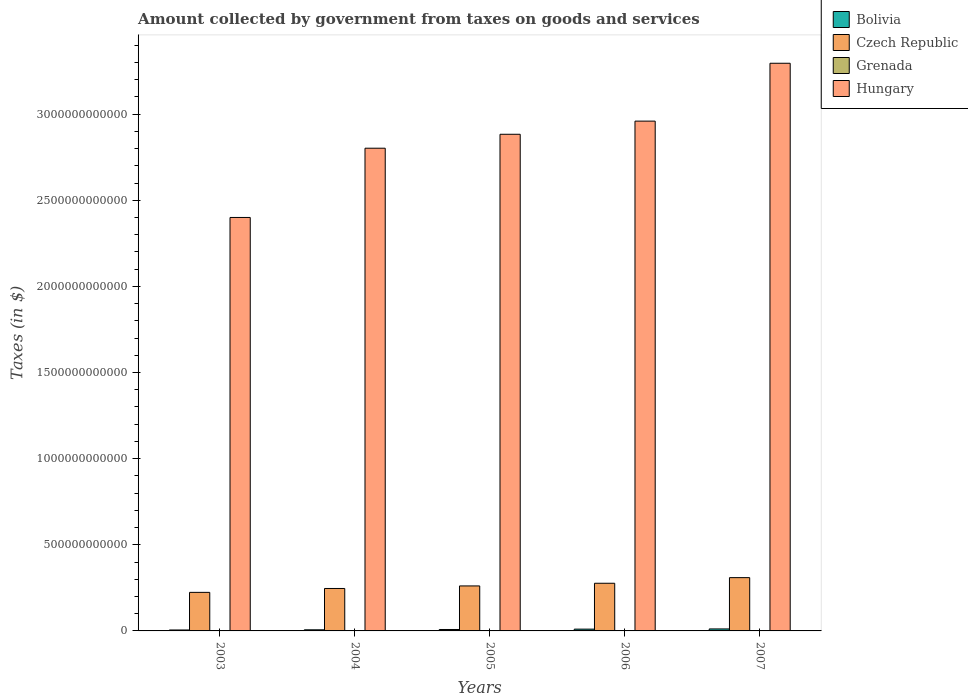Are the number of bars per tick equal to the number of legend labels?
Offer a terse response. Yes. How many bars are there on the 5th tick from the left?
Provide a succinct answer. 4. How many bars are there on the 5th tick from the right?
Your answer should be compact. 4. What is the label of the 2nd group of bars from the left?
Provide a succinct answer. 2004. What is the amount collected by government from taxes on goods and services in Czech Republic in 2003?
Your answer should be very brief. 2.24e+11. Across all years, what is the maximum amount collected by government from taxes on goods and services in Bolivia?
Give a very brief answer. 1.15e+1. Across all years, what is the minimum amount collected by government from taxes on goods and services in Czech Republic?
Provide a succinct answer. 2.24e+11. In which year was the amount collected by government from taxes on goods and services in Grenada minimum?
Your response must be concise. 2004. What is the total amount collected by government from taxes on goods and services in Grenada in the graph?
Offer a very short reply. 3.11e+08. What is the difference between the amount collected by government from taxes on goods and services in Grenada in 2005 and that in 2006?
Give a very brief answer. -9.10e+06. What is the difference between the amount collected by government from taxes on goods and services in Hungary in 2007 and the amount collected by government from taxes on goods and services in Czech Republic in 2006?
Make the answer very short. 3.02e+12. What is the average amount collected by government from taxes on goods and services in Czech Republic per year?
Your answer should be very brief. 2.63e+11. In the year 2006, what is the difference between the amount collected by government from taxes on goods and services in Czech Republic and amount collected by government from taxes on goods and services in Grenada?
Offer a terse response. 2.77e+11. In how many years, is the amount collected by government from taxes on goods and services in Hungary greater than 1200000000000 $?
Your answer should be very brief. 5. What is the ratio of the amount collected by government from taxes on goods and services in Bolivia in 2006 to that in 2007?
Give a very brief answer. 0.9. Is the amount collected by government from taxes on goods and services in Bolivia in 2003 less than that in 2004?
Make the answer very short. Yes. Is the difference between the amount collected by government from taxes on goods and services in Czech Republic in 2006 and 2007 greater than the difference between the amount collected by government from taxes on goods and services in Grenada in 2006 and 2007?
Provide a succinct answer. No. What is the difference between the highest and the second highest amount collected by government from taxes on goods and services in Grenada?
Your response must be concise. 2.30e+06. What is the difference between the highest and the lowest amount collected by government from taxes on goods and services in Bolivia?
Ensure brevity in your answer.  6.09e+09. Is the sum of the amount collected by government from taxes on goods and services in Grenada in 2003 and 2006 greater than the maximum amount collected by government from taxes on goods and services in Czech Republic across all years?
Make the answer very short. No. What does the 2nd bar from the left in 2005 represents?
Make the answer very short. Czech Republic. What does the 2nd bar from the right in 2005 represents?
Make the answer very short. Grenada. How many bars are there?
Make the answer very short. 20. How many years are there in the graph?
Your answer should be compact. 5. What is the difference between two consecutive major ticks on the Y-axis?
Make the answer very short. 5.00e+11. Does the graph contain any zero values?
Keep it short and to the point. No. What is the title of the graph?
Offer a very short reply. Amount collected by government from taxes on goods and services. Does "Kiribati" appear as one of the legend labels in the graph?
Your answer should be very brief. No. What is the label or title of the X-axis?
Give a very brief answer. Years. What is the label or title of the Y-axis?
Provide a succinct answer. Taxes (in $). What is the Taxes (in $) of Bolivia in 2003?
Your response must be concise. 5.45e+09. What is the Taxes (in $) of Czech Republic in 2003?
Ensure brevity in your answer.  2.24e+11. What is the Taxes (in $) of Grenada in 2003?
Ensure brevity in your answer.  5.90e+07. What is the Taxes (in $) of Hungary in 2003?
Provide a short and direct response. 2.40e+12. What is the Taxes (in $) in Bolivia in 2004?
Your answer should be compact. 6.44e+09. What is the Taxes (in $) in Czech Republic in 2004?
Offer a very short reply. 2.46e+11. What is the Taxes (in $) of Grenada in 2004?
Your answer should be compact. 5.20e+07. What is the Taxes (in $) in Hungary in 2004?
Ensure brevity in your answer.  2.80e+12. What is the Taxes (in $) of Bolivia in 2005?
Provide a short and direct response. 8.30e+09. What is the Taxes (in $) of Czech Republic in 2005?
Provide a succinct answer. 2.61e+11. What is the Taxes (in $) of Grenada in 2005?
Offer a very short reply. 5.99e+07. What is the Taxes (in $) in Hungary in 2005?
Your answer should be compact. 2.88e+12. What is the Taxes (in $) in Bolivia in 2006?
Your answer should be compact. 1.04e+1. What is the Taxes (in $) of Czech Republic in 2006?
Your answer should be compact. 2.77e+11. What is the Taxes (in $) in Grenada in 2006?
Give a very brief answer. 6.90e+07. What is the Taxes (in $) of Hungary in 2006?
Offer a terse response. 2.96e+12. What is the Taxes (in $) of Bolivia in 2007?
Keep it short and to the point. 1.15e+1. What is the Taxes (in $) of Czech Republic in 2007?
Offer a very short reply. 3.09e+11. What is the Taxes (in $) of Grenada in 2007?
Your answer should be very brief. 7.13e+07. What is the Taxes (in $) in Hungary in 2007?
Provide a short and direct response. 3.30e+12. Across all years, what is the maximum Taxes (in $) of Bolivia?
Provide a short and direct response. 1.15e+1. Across all years, what is the maximum Taxes (in $) of Czech Republic?
Your response must be concise. 3.09e+11. Across all years, what is the maximum Taxes (in $) in Grenada?
Offer a terse response. 7.13e+07. Across all years, what is the maximum Taxes (in $) of Hungary?
Ensure brevity in your answer.  3.30e+12. Across all years, what is the minimum Taxes (in $) in Bolivia?
Offer a very short reply. 5.45e+09. Across all years, what is the minimum Taxes (in $) of Czech Republic?
Your answer should be very brief. 2.24e+11. Across all years, what is the minimum Taxes (in $) of Grenada?
Your response must be concise. 5.20e+07. Across all years, what is the minimum Taxes (in $) in Hungary?
Offer a terse response. 2.40e+12. What is the total Taxes (in $) of Bolivia in the graph?
Give a very brief answer. 4.21e+1. What is the total Taxes (in $) of Czech Republic in the graph?
Ensure brevity in your answer.  1.32e+12. What is the total Taxes (in $) of Grenada in the graph?
Your response must be concise. 3.11e+08. What is the total Taxes (in $) in Hungary in the graph?
Your response must be concise. 1.43e+13. What is the difference between the Taxes (in $) of Bolivia in 2003 and that in 2004?
Offer a terse response. -9.93e+08. What is the difference between the Taxes (in $) in Czech Republic in 2003 and that in 2004?
Your answer should be very brief. -2.25e+1. What is the difference between the Taxes (in $) in Hungary in 2003 and that in 2004?
Your response must be concise. -4.02e+11. What is the difference between the Taxes (in $) in Bolivia in 2003 and that in 2005?
Your answer should be compact. -2.85e+09. What is the difference between the Taxes (in $) in Czech Republic in 2003 and that in 2005?
Your answer should be very brief. -3.73e+1. What is the difference between the Taxes (in $) of Grenada in 2003 and that in 2005?
Provide a short and direct response. -9.00e+05. What is the difference between the Taxes (in $) in Hungary in 2003 and that in 2005?
Provide a short and direct response. -4.83e+11. What is the difference between the Taxes (in $) of Bolivia in 2003 and that in 2006?
Give a very brief answer. -4.92e+09. What is the difference between the Taxes (in $) in Czech Republic in 2003 and that in 2006?
Offer a very short reply. -5.28e+1. What is the difference between the Taxes (in $) in Grenada in 2003 and that in 2006?
Keep it short and to the point. -1.00e+07. What is the difference between the Taxes (in $) of Hungary in 2003 and that in 2006?
Provide a succinct answer. -5.59e+11. What is the difference between the Taxes (in $) in Bolivia in 2003 and that in 2007?
Make the answer very short. -6.09e+09. What is the difference between the Taxes (in $) of Czech Republic in 2003 and that in 2007?
Your answer should be compact. -8.55e+1. What is the difference between the Taxes (in $) of Grenada in 2003 and that in 2007?
Keep it short and to the point. -1.23e+07. What is the difference between the Taxes (in $) of Hungary in 2003 and that in 2007?
Your answer should be very brief. -8.95e+11. What is the difference between the Taxes (in $) in Bolivia in 2004 and that in 2005?
Provide a short and direct response. -1.86e+09. What is the difference between the Taxes (in $) of Czech Republic in 2004 and that in 2005?
Give a very brief answer. -1.48e+1. What is the difference between the Taxes (in $) in Grenada in 2004 and that in 2005?
Ensure brevity in your answer.  -7.90e+06. What is the difference between the Taxes (in $) in Hungary in 2004 and that in 2005?
Your answer should be very brief. -8.09e+1. What is the difference between the Taxes (in $) in Bolivia in 2004 and that in 2006?
Keep it short and to the point. -3.92e+09. What is the difference between the Taxes (in $) in Czech Republic in 2004 and that in 2006?
Keep it short and to the point. -3.03e+1. What is the difference between the Taxes (in $) in Grenada in 2004 and that in 2006?
Ensure brevity in your answer.  -1.70e+07. What is the difference between the Taxes (in $) in Hungary in 2004 and that in 2006?
Give a very brief answer. -1.57e+11. What is the difference between the Taxes (in $) of Bolivia in 2004 and that in 2007?
Keep it short and to the point. -5.10e+09. What is the difference between the Taxes (in $) in Czech Republic in 2004 and that in 2007?
Provide a succinct answer. -6.29e+1. What is the difference between the Taxes (in $) in Grenada in 2004 and that in 2007?
Keep it short and to the point. -1.93e+07. What is the difference between the Taxes (in $) in Hungary in 2004 and that in 2007?
Ensure brevity in your answer.  -4.93e+11. What is the difference between the Taxes (in $) of Bolivia in 2005 and that in 2006?
Your response must be concise. -2.06e+09. What is the difference between the Taxes (in $) in Czech Republic in 2005 and that in 2006?
Your answer should be very brief. -1.55e+1. What is the difference between the Taxes (in $) in Grenada in 2005 and that in 2006?
Offer a terse response. -9.10e+06. What is the difference between the Taxes (in $) in Hungary in 2005 and that in 2006?
Offer a very short reply. -7.64e+1. What is the difference between the Taxes (in $) of Bolivia in 2005 and that in 2007?
Your response must be concise. -3.24e+09. What is the difference between the Taxes (in $) of Czech Republic in 2005 and that in 2007?
Your answer should be very brief. -4.82e+1. What is the difference between the Taxes (in $) of Grenada in 2005 and that in 2007?
Provide a succinct answer. -1.14e+07. What is the difference between the Taxes (in $) in Hungary in 2005 and that in 2007?
Offer a very short reply. -4.12e+11. What is the difference between the Taxes (in $) in Bolivia in 2006 and that in 2007?
Give a very brief answer. -1.18e+09. What is the difference between the Taxes (in $) of Czech Republic in 2006 and that in 2007?
Offer a very short reply. -3.26e+1. What is the difference between the Taxes (in $) in Grenada in 2006 and that in 2007?
Offer a terse response. -2.30e+06. What is the difference between the Taxes (in $) of Hungary in 2006 and that in 2007?
Offer a terse response. -3.36e+11. What is the difference between the Taxes (in $) in Bolivia in 2003 and the Taxes (in $) in Czech Republic in 2004?
Offer a very short reply. -2.41e+11. What is the difference between the Taxes (in $) in Bolivia in 2003 and the Taxes (in $) in Grenada in 2004?
Provide a short and direct response. 5.39e+09. What is the difference between the Taxes (in $) in Bolivia in 2003 and the Taxes (in $) in Hungary in 2004?
Provide a succinct answer. -2.80e+12. What is the difference between the Taxes (in $) in Czech Republic in 2003 and the Taxes (in $) in Grenada in 2004?
Offer a very short reply. 2.24e+11. What is the difference between the Taxes (in $) of Czech Republic in 2003 and the Taxes (in $) of Hungary in 2004?
Make the answer very short. -2.58e+12. What is the difference between the Taxes (in $) in Grenada in 2003 and the Taxes (in $) in Hungary in 2004?
Give a very brief answer. -2.80e+12. What is the difference between the Taxes (in $) in Bolivia in 2003 and the Taxes (in $) in Czech Republic in 2005?
Make the answer very short. -2.56e+11. What is the difference between the Taxes (in $) in Bolivia in 2003 and the Taxes (in $) in Grenada in 2005?
Provide a short and direct response. 5.39e+09. What is the difference between the Taxes (in $) in Bolivia in 2003 and the Taxes (in $) in Hungary in 2005?
Provide a short and direct response. -2.88e+12. What is the difference between the Taxes (in $) in Czech Republic in 2003 and the Taxes (in $) in Grenada in 2005?
Ensure brevity in your answer.  2.24e+11. What is the difference between the Taxes (in $) of Czech Republic in 2003 and the Taxes (in $) of Hungary in 2005?
Your response must be concise. -2.66e+12. What is the difference between the Taxes (in $) in Grenada in 2003 and the Taxes (in $) in Hungary in 2005?
Your answer should be very brief. -2.88e+12. What is the difference between the Taxes (in $) of Bolivia in 2003 and the Taxes (in $) of Czech Republic in 2006?
Offer a terse response. -2.71e+11. What is the difference between the Taxes (in $) of Bolivia in 2003 and the Taxes (in $) of Grenada in 2006?
Offer a terse response. 5.38e+09. What is the difference between the Taxes (in $) in Bolivia in 2003 and the Taxes (in $) in Hungary in 2006?
Offer a terse response. -2.95e+12. What is the difference between the Taxes (in $) of Czech Republic in 2003 and the Taxes (in $) of Grenada in 2006?
Provide a short and direct response. 2.24e+11. What is the difference between the Taxes (in $) in Czech Republic in 2003 and the Taxes (in $) in Hungary in 2006?
Give a very brief answer. -2.74e+12. What is the difference between the Taxes (in $) of Grenada in 2003 and the Taxes (in $) of Hungary in 2006?
Your answer should be compact. -2.96e+12. What is the difference between the Taxes (in $) in Bolivia in 2003 and the Taxes (in $) in Czech Republic in 2007?
Your answer should be compact. -3.04e+11. What is the difference between the Taxes (in $) of Bolivia in 2003 and the Taxes (in $) of Grenada in 2007?
Your response must be concise. 5.38e+09. What is the difference between the Taxes (in $) in Bolivia in 2003 and the Taxes (in $) in Hungary in 2007?
Ensure brevity in your answer.  -3.29e+12. What is the difference between the Taxes (in $) of Czech Republic in 2003 and the Taxes (in $) of Grenada in 2007?
Your answer should be very brief. 2.24e+11. What is the difference between the Taxes (in $) in Czech Republic in 2003 and the Taxes (in $) in Hungary in 2007?
Give a very brief answer. -3.07e+12. What is the difference between the Taxes (in $) in Grenada in 2003 and the Taxes (in $) in Hungary in 2007?
Your answer should be very brief. -3.30e+12. What is the difference between the Taxes (in $) in Bolivia in 2004 and the Taxes (in $) in Czech Republic in 2005?
Offer a terse response. -2.55e+11. What is the difference between the Taxes (in $) in Bolivia in 2004 and the Taxes (in $) in Grenada in 2005?
Your answer should be compact. 6.38e+09. What is the difference between the Taxes (in $) of Bolivia in 2004 and the Taxes (in $) of Hungary in 2005?
Offer a terse response. -2.88e+12. What is the difference between the Taxes (in $) in Czech Republic in 2004 and the Taxes (in $) in Grenada in 2005?
Your answer should be compact. 2.46e+11. What is the difference between the Taxes (in $) in Czech Republic in 2004 and the Taxes (in $) in Hungary in 2005?
Keep it short and to the point. -2.64e+12. What is the difference between the Taxes (in $) in Grenada in 2004 and the Taxes (in $) in Hungary in 2005?
Keep it short and to the point. -2.88e+12. What is the difference between the Taxes (in $) in Bolivia in 2004 and the Taxes (in $) in Czech Republic in 2006?
Offer a very short reply. -2.70e+11. What is the difference between the Taxes (in $) in Bolivia in 2004 and the Taxes (in $) in Grenada in 2006?
Your answer should be very brief. 6.37e+09. What is the difference between the Taxes (in $) of Bolivia in 2004 and the Taxes (in $) of Hungary in 2006?
Provide a succinct answer. -2.95e+12. What is the difference between the Taxes (in $) in Czech Republic in 2004 and the Taxes (in $) in Grenada in 2006?
Provide a succinct answer. 2.46e+11. What is the difference between the Taxes (in $) in Czech Republic in 2004 and the Taxes (in $) in Hungary in 2006?
Your answer should be compact. -2.71e+12. What is the difference between the Taxes (in $) of Grenada in 2004 and the Taxes (in $) of Hungary in 2006?
Give a very brief answer. -2.96e+12. What is the difference between the Taxes (in $) of Bolivia in 2004 and the Taxes (in $) of Czech Republic in 2007?
Ensure brevity in your answer.  -3.03e+11. What is the difference between the Taxes (in $) of Bolivia in 2004 and the Taxes (in $) of Grenada in 2007?
Your answer should be compact. 6.37e+09. What is the difference between the Taxes (in $) of Bolivia in 2004 and the Taxes (in $) of Hungary in 2007?
Provide a short and direct response. -3.29e+12. What is the difference between the Taxes (in $) in Czech Republic in 2004 and the Taxes (in $) in Grenada in 2007?
Give a very brief answer. 2.46e+11. What is the difference between the Taxes (in $) in Czech Republic in 2004 and the Taxes (in $) in Hungary in 2007?
Your response must be concise. -3.05e+12. What is the difference between the Taxes (in $) of Grenada in 2004 and the Taxes (in $) of Hungary in 2007?
Make the answer very short. -3.30e+12. What is the difference between the Taxes (in $) in Bolivia in 2005 and the Taxes (in $) in Czech Republic in 2006?
Give a very brief answer. -2.68e+11. What is the difference between the Taxes (in $) of Bolivia in 2005 and the Taxes (in $) of Grenada in 2006?
Offer a very short reply. 8.23e+09. What is the difference between the Taxes (in $) in Bolivia in 2005 and the Taxes (in $) in Hungary in 2006?
Ensure brevity in your answer.  -2.95e+12. What is the difference between the Taxes (in $) of Czech Republic in 2005 and the Taxes (in $) of Grenada in 2006?
Offer a very short reply. 2.61e+11. What is the difference between the Taxes (in $) of Czech Republic in 2005 and the Taxes (in $) of Hungary in 2006?
Provide a short and direct response. -2.70e+12. What is the difference between the Taxes (in $) of Grenada in 2005 and the Taxes (in $) of Hungary in 2006?
Your response must be concise. -2.96e+12. What is the difference between the Taxes (in $) of Bolivia in 2005 and the Taxes (in $) of Czech Republic in 2007?
Keep it short and to the point. -3.01e+11. What is the difference between the Taxes (in $) of Bolivia in 2005 and the Taxes (in $) of Grenada in 2007?
Your answer should be very brief. 8.23e+09. What is the difference between the Taxes (in $) in Bolivia in 2005 and the Taxes (in $) in Hungary in 2007?
Your answer should be compact. -3.29e+12. What is the difference between the Taxes (in $) of Czech Republic in 2005 and the Taxes (in $) of Grenada in 2007?
Keep it short and to the point. 2.61e+11. What is the difference between the Taxes (in $) in Czech Republic in 2005 and the Taxes (in $) in Hungary in 2007?
Your response must be concise. -3.03e+12. What is the difference between the Taxes (in $) of Grenada in 2005 and the Taxes (in $) of Hungary in 2007?
Provide a succinct answer. -3.30e+12. What is the difference between the Taxes (in $) in Bolivia in 2006 and the Taxes (in $) in Czech Republic in 2007?
Provide a short and direct response. -2.99e+11. What is the difference between the Taxes (in $) of Bolivia in 2006 and the Taxes (in $) of Grenada in 2007?
Offer a terse response. 1.03e+1. What is the difference between the Taxes (in $) of Bolivia in 2006 and the Taxes (in $) of Hungary in 2007?
Provide a short and direct response. -3.28e+12. What is the difference between the Taxes (in $) in Czech Republic in 2006 and the Taxes (in $) in Grenada in 2007?
Provide a short and direct response. 2.77e+11. What is the difference between the Taxes (in $) of Czech Republic in 2006 and the Taxes (in $) of Hungary in 2007?
Your answer should be very brief. -3.02e+12. What is the difference between the Taxes (in $) in Grenada in 2006 and the Taxes (in $) in Hungary in 2007?
Make the answer very short. -3.30e+12. What is the average Taxes (in $) of Bolivia per year?
Your answer should be compact. 8.42e+09. What is the average Taxes (in $) of Czech Republic per year?
Provide a succinct answer. 2.63e+11. What is the average Taxes (in $) in Grenada per year?
Provide a short and direct response. 6.22e+07. What is the average Taxes (in $) in Hungary per year?
Offer a very short reply. 2.87e+12. In the year 2003, what is the difference between the Taxes (in $) of Bolivia and Taxes (in $) of Czech Republic?
Ensure brevity in your answer.  -2.18e+11. In the year 2003, what is the difference between the Taxes (in $) in Bolivia and Taxes (in $) in Grenada?
Provide a short and direct response. 5.39e+09. In the year 2003, what is the difference between the Taxes (in $) in Bolivia and Taxes (in $) in Hungary?
Provide a succinct answer. -2.39e+12. In the year 2003, what is the difference between the Taxes (in $) in Czech Republic and Taxes (in $) in Grenada?
Your answer should be compact. 2.24e+11. In the year 2003, what is the difference between the Taxes (in $) in Czech Republic and Taxes (in $) in Hungary?
Your answer should be very brief. -2.18e+12. In the year 2003, what is the difference between the Taxes (in $) of Grenada and Taxes (in $) of Hungary?
Offer a very short reply. -2.40e+12. In the year 2004, what is the difference between the Taxes (in $) of Bolivia and Taxes (in $) of Czech Republic?
Ensure brevity in your answer.  -2.40e+11. In the year 2004, what is the difference between the Taxes (in $) in Bolivia and Taxes (in $) in Grenada?
Keep it short and to the point. 6.39e+09. In the year 2004, what is the difference between the Taxes (in $) of Bolivia and Taxes (in $) of Hungary?
Make the answer very short. -2.80e+12. In the year 2004, what is the difference between the Taxes (in $) in Czech Republic and Taxes (in $) in Grenada?
Your answer should be compact. 2.46e+11. In the year 2004, what is the difference between the Taxes (in $) in Czech Republic and Taxes (in $) in Hungary?
Offer a very short reply. -2.56e+12. In the year 2004, what is the difference between the Taxes (in $) of Grenada and Taxes (in $) of Hungary?
Ensure brevity in your answer.  -2.80e+12. In the year 2005, what is the difference between the Taxes (in $) in Bolivia and Taxes (in $) in Czech Republic?
Offer a terse response. -2.53e+11. In the year 2005, what is the difference between the Taxes (in $) of Bolivia and Taxes (in $) of Grenada?
Provide a short and direct response. 8.24e+09. In the year 2005, what is the difference between the Taxes (in $) of Bolivia and Taxes (in $) of Hungary?
Offer a terse response. -2.87e+12. In the year 2005, what is the difference between the Taxes (in $) of Czech Republic and Taxes (in $) of Grenada?
Make the answer very short. 2.61e+11. In the year 2005, what is the difference between the Taxes (in $) in Czech Republic and Taxes (in $) in Hungary?
Offer a terse response. -2.62e+12. In the year 2005, what is the difference between the Taxes (in $) of Grenada and Taxes (in $) of Hungary?
Make the answer very short. -2.88e+12. In the year 2006, what is the difference between the Taxes (in $) in Bolivia and Taxes (in $) in Czech Republic?
Offer a very short reply. -2.66e+11. In the year 2006, what is the difference between the Taxes (in $) in Bolivia and Taxes (in $) in Grenada?
Keep it short and to the point. 1.03e+1. In the year 2006, what is the difference between the Taxes (in $) of Bolivia and Taxes (in $) of Hungary?
Provide a succinct answer. -2.95e+12. In the year 2006, what is the difference between the Taxes (in $) of Czech Republic and Taxes (in $) of Grenada?
Ensure brevity in your answer.  2.77e+11. In the year 2006, what is the difference between the Taxes (in $) of Czech Republic and Taxes (in $) of Hungary?
Your answer should be compact. -2.68e+12. In the year 2006, what is the difference between the Taxes (in $) of Grenada and Taxes (in $) of Hungary?
Your answer should be compact. -2.96e+12. In the year 2007, what is the difference between the Taxes (in $) of Bolivia and Taxes (in $) of Czech Republic?
Keep it short and to the point. -2.98e+11. In the year 2007, what is the difference between the Taxes (in $) in Bolivia and Taxes (in $) in Grenada?
Offer a terse response. 1.15e+1. In the year 2007, what is the difference between the Taxes (in $) of Bolivia and Taxes (in $) of Hungary?
Keep it short and to the point. -3.28e+12. In the year 2007, what is the difference between the Taxes (in $) of Czech Republic and Taxes (in $) of Grenada?
Offer a terse response. 3.09e+11. In the year 2007, what is the difference between the Taxes (in $) of Czech Republic and Taxes (in $) of Hungary?
Ensure brevity in your answer.  -2.99e+12. In the year 2007, what is the difference between the Taxes (in $) in Grenada and Taxes (in $) in Hungary?
Your response must be concise. -3.30e+12. What is the ratio of the Taxes (in $) in Bolivia in 2003 to that in 2004?
Give a very brief answer. 0.85. What is the ratio of the Taxes (in $) in Czech Republic in 2003 to that in 2004?
Keep it short and to the point. 0.91. What is the ratio of the Taxes (in $) of Grenada in 2003 to that in 2004?
Provide a succinct answer. 1.13. What is the ratio of the Taxes (in $) of Hungary in 2003 to that in 2004?
Ensure brevity in your answer.  0.86. What is the ratio of the Taxes (in $) in Bolivia in 2003 to that in 2005?
Provide a succinct answer. 0.66. What is the ratio of the Taxes (in $) of Grenada in 2003 to that in 2005?
Provide a short and direct response. 0.98. What is the ratio of the Taxes (in $) of Hungary in 2003 to that in 2005?
Provide a short and direct response. 0.83. What is the ratio of the Taxes (in $) in Bolivia in 2003 to that in 2006?
Your answer should be very brief. 0.53. What is the ratio of the Taxes (in $) of Czech Republic in 2003 to that in 2006?
Your response must be concise. 0.81. What is the ratio of the Taxes (in $) of Grenada in 2003 to that in 2006?
Your answer should be very brief. 0.86. What is the ratio of the Taxes (in $) in Hungary in 2003 to that in 2006?
Your answer should be compact. 0.81. What is the ratio of the Taxes (in $) in Bolivia in 2003 to that in 2007?
Offer a terse response. 0.47. What is the ratio of the Taxes (in $) in Czech Republic in 2003 to that in 2007?
Offer a very short reply. 0.72. What is the ratio of the Taxes (in $) of Grenada in 2003 to that in 2007?
Your answer should be very brief. 0.83. What is the ratio of the Taxes (in $) of Hungary in 2003 to that in 2007?
Provide a succinct answer. 0.73. What is the ratio of the Taxes (in $) of Bolivia in 2004 to that in 2005?
Ensure brevity in your answer.  0.78. What is the ratio of the Taxes (in $) of Czech Republic in 2004 to that in 2005?
Give a very brief answer. 0.94. What is the ratio of the Taxes (in $) in Grenada in 2004 to that in 2005?
Provide a succinct answer. 0.87. What is the ratio of the Taxes (in $) of Hungary in 2004 to that in 2005?
Provide a succinct answer. 0.97. What is the ratio of the Taxes (in $) of Bolivia in 2004 to that in 2006?
Ensure brevity in your answer.  0.62. What is the ratio of the Taxes (in $) of Czech Republic in 2004 to that in 2006?
Offer a very short reply. 0.89. What is the ratio of the Taxes (in $) in Grenada in 2004 to that in 2006?
Keep it short and to the point. 0.75. What is the ratio of the Taxes (in $) in Hungary in 2004 to that in 2006?
Keep it short and to the point. 0.95. What is the ratio of the Taxes (in $) in Bolivia in 2004 to that in 2007?
Give a very brief answer. 0.56. What is the ratio of the Taxes (in $) of Czech Republic in 2004 to that in 2007?
Your answer should be compact. 0.8. What is the ratio of the Taxes (in $) in Grenada in 2004 to that in 2007?
Keep it short and to the point. 0.73. What is the ratio of the Taxes (in $) of Hungary in 2004 to that in 2007?
Your answer should be compact. 0.85. What is the ratio of the Taxes (in $) in Bolivia in 2005 to that in 2006?
Provide a succinct answer. 0.8. What is the ratio of the Taxes (in $) in Czech Republic in 2005 to that in 2006?
Make the answer very short. 0.94. What is the ratio of the Taxes (in $) of Grenada in 2005 to that in 2006?
Offer a terse response. 0.87. What is the ratio of the Taxes (in $) in Hungary in 2005 to that in 2006?
Provide a short and direct response. 0.97. What is the ratio of the Taxes (in $) of Bolivia in 2005 to that in 2007?
Your answer should be very brief. 0.72. What is the ratio of the Taxes (in $) of Czech Republic in 2005 to that in 2007?
Your answer should be very brief. 0.84. What is the ratio of the Taxes (in $) of Grenada in 2005 to that in 2007?
Offer a very short reply. 0.84. What is the ratio of the Taxes (in $) of Hungary in 2005 to that in 2007?
Your answer should be very brief. 0.87. What is the ratio of the Taxes (in $) in Bolivia in 2006 to that in 2007?
Offer a very short reply. 0.9. What is the ratio of the Taxes (in $) of Czech Republic in 2006 to that in 2007?
Give a very brief answer. 0.89. What is the ratio of the Taxes (in $) of Hungary in 2006 to that in 2007?
Give a very brief answer. 0.9. What is the difference between the highest and the second highest Taxes (in $) in Bolivia?
Make the answer very short. 1.18e+09. What is the difference between the highest and the second highest Taxes (in $) of Czech Republic?
Give a very brief answer. 3.26e+1. What is the difference between the highest and the second highest Taxes (in $) of Grenada?
Provide a short and direct response. 2.30e+06. What is the difference between the highest and the second highest Taxes (in $) in Hungary?
Offer a terse response. 3.36e+11. What is the difference between the highest and the lowest Taxes (in $) of Bolivia?
Your response must be concise. 6.09e+09. What is the difference between the highest and the lowest Taxes (in $) in Czech Republic?
Keep it short and to the point. 8.55e+1. What is the difference between the highest and the lowest Taxes (in $) in Grenada?
Provide a short and direct response. 1.93e+07. What is the difference between the highest and the lowest Taxes (in $) of Hungary?
Keep it short and to the point. 8.95e+11. 